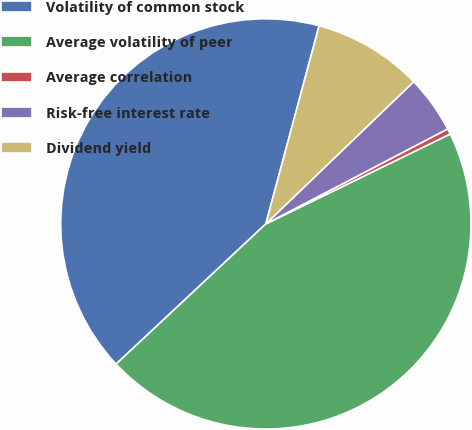<chart> <loc_0><loc_0><loc_500><loc_500><pie_chart><fcel>Volatility of common stock<fcel>Average volatility of peer<fcel>Average correlation<fcel>Risk-free interest rate<fcel>Dividend yield<nl><fcel>41.16%<fcel>45.25%<fcel>0.44%<fcel>4.53%<fcel>8.63%<nl></chart> 